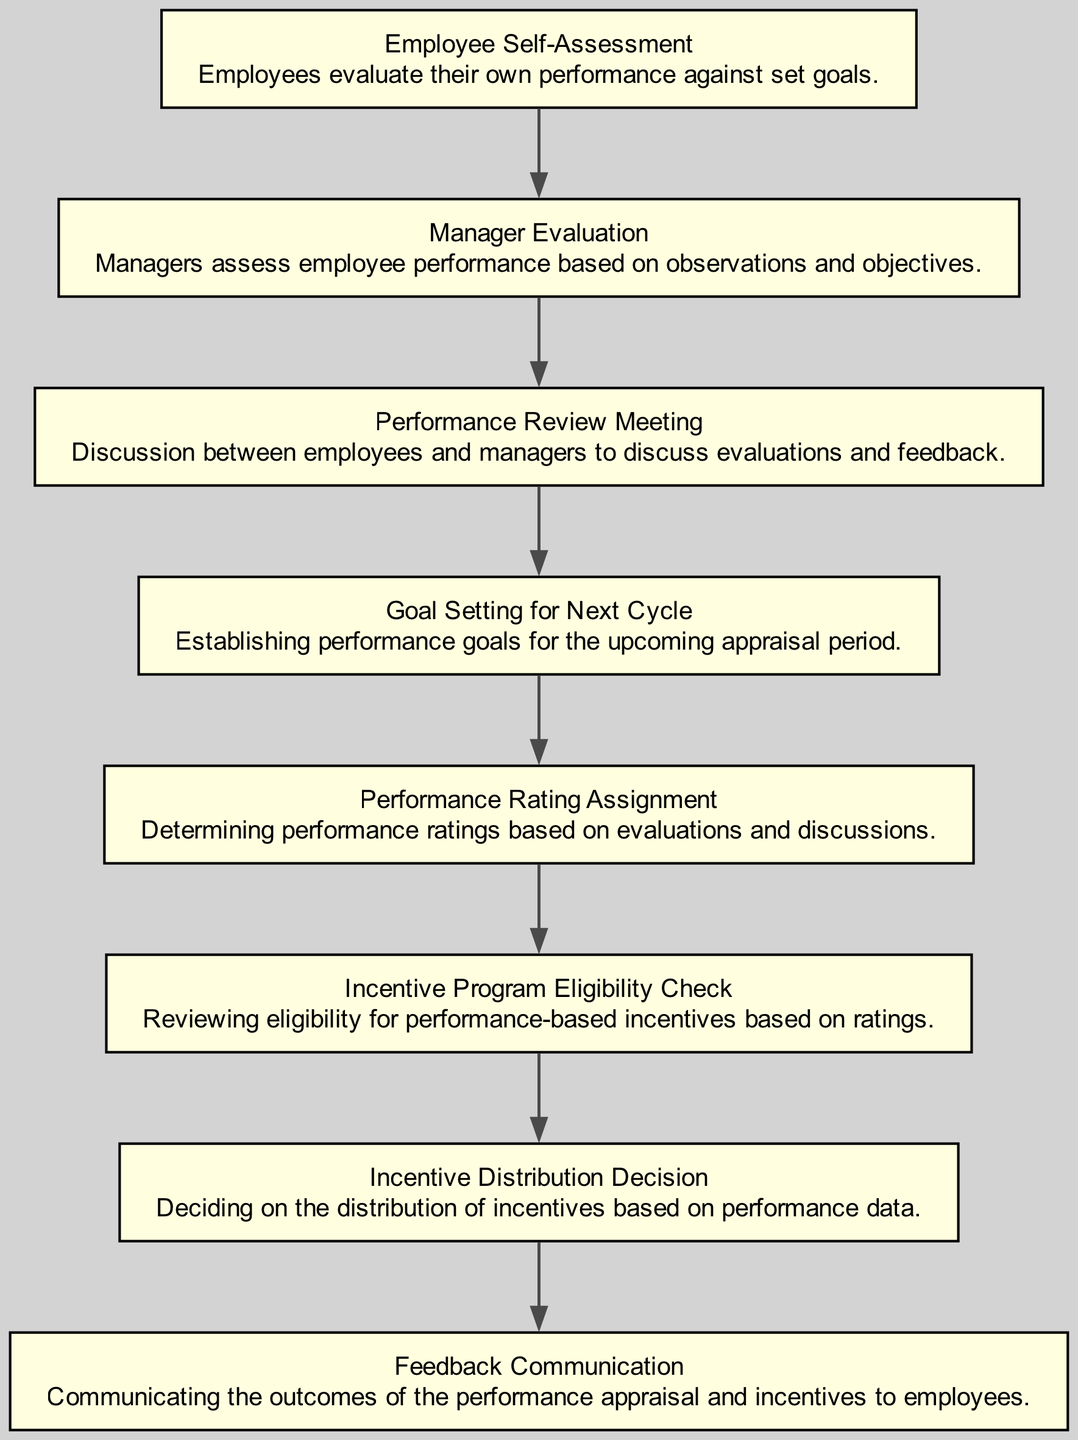What is the first step in the performance appraisal process? The first step, according to the diagram, is "Employee Self-Assessment," where employees evaluate their own performance against set goals.
Answer: Employee Self-Assessment How many nodes are there in the diagram? The diagram has 8 nodes representing each step in the performance appraisal process.
Answer: 8 What step follows the "Manager Evaluation"? After "Manager Evaluation," the next step is "Performance Review Meeting."
Answer: Performance Review Meeting Which step occurs just before "Incentive Distribution Decision"? "Incentive Program Eligibility Check" happens immediately before "Incentive Distribution Decision," ensuring that employees meet criteria for receiving incentives.
Answer: Incentive Program Eligibility Check What is the relationship between "Goal Setting for Next Cycle" and "Performance Rating Assignment"? "Goal Setting for Next Cycle" is followed by "Performance Rating Assignment," indicating that goals are established before ratings are assigned.
Answer: Goal Setting for Next Cycle → Performance Rating Assignment What is the purpose of the "Feedback Communication" step? The "Feedback Communication" step serves to communicate the outcomes of the performance appraisal and the incentive distribution to employees.
Answer: Communicate outcomes Which node determines the performance ratings? The node that determines performance ratings is "Performance Rating Assignment," which consolidates evaluations and discussions to assign ratings.
Answer: Performance Rating Assignment Is the "Manager Evaluation" step independent of the "Employee Self-Assessment"? No, the "Manager Evaluation" step directly depends on the completion of the "Employee Self-Assessment," indicating a sequential relationship in the process.
Answer: No What is the last step in the performance appraisal process? The last step in the process is "Feedback Communication," which finalizes the appraisal by informing employees of the results and any incentives.
Answer: Feedback Communication 